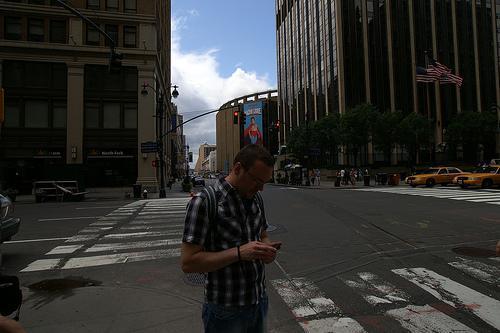How many buildings have flags in front of them?
Give a very brief answer. 1. 